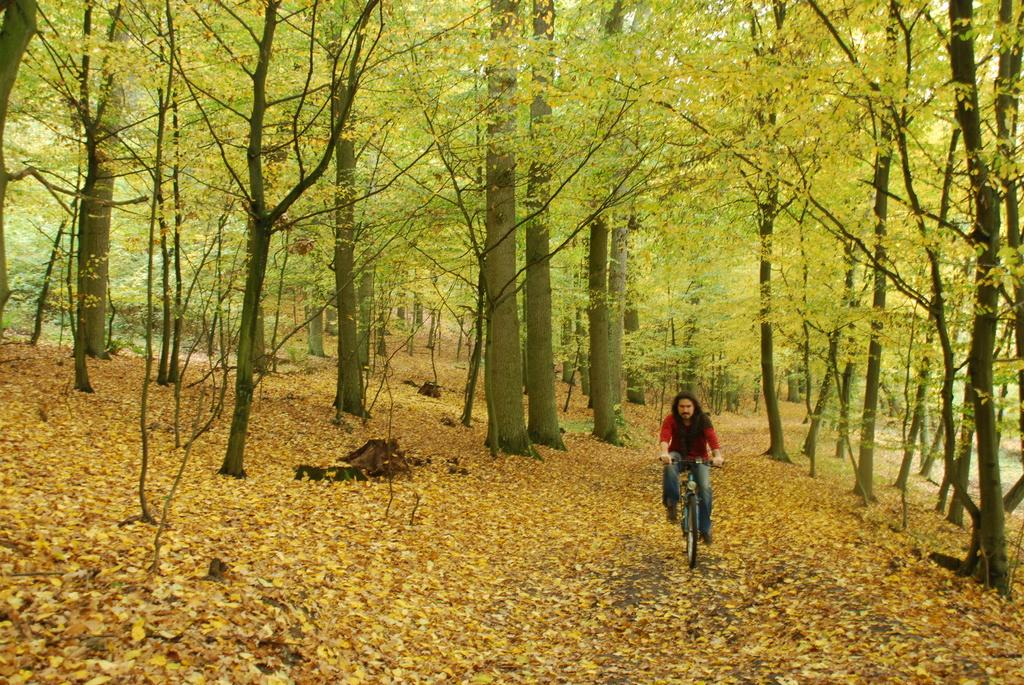What is the person in the image doing? There is a person riding a cycle in the image. What can be seen on the ground in the image? There are leaves on the ground in the image. What type of vegetation is present in the image? There are trees in the image. What type of cake is being served on the glass table in the image? There is no cake or glass table present in the image; it features a person riding a cycle and trees in the background. 